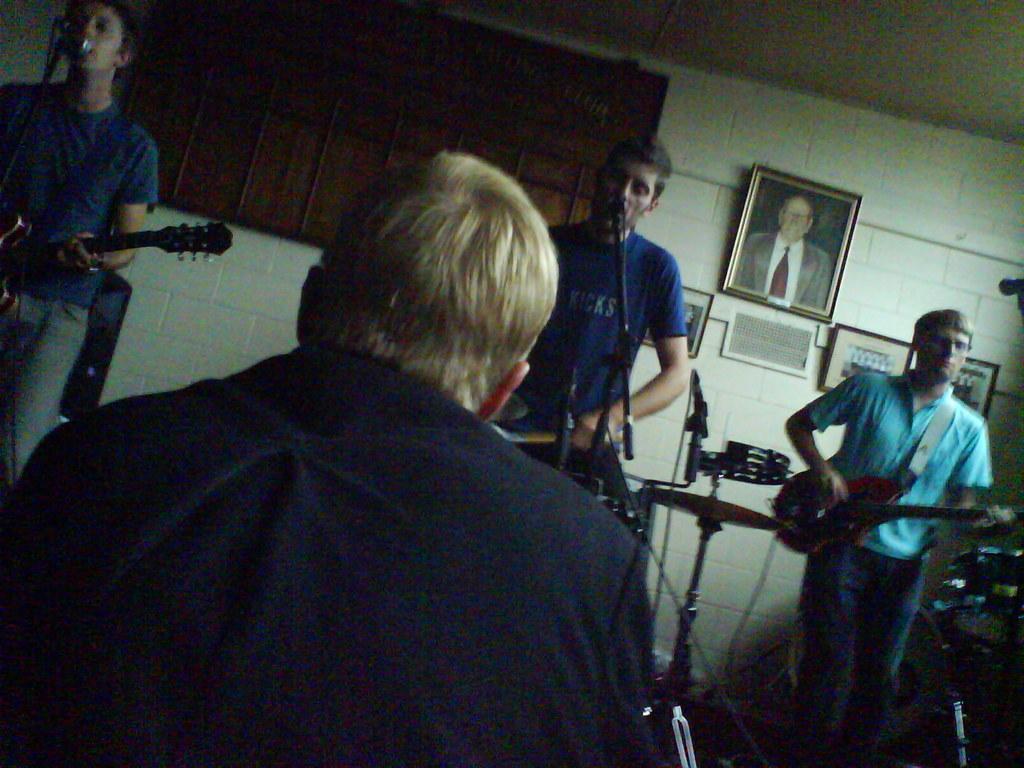How would you summarize this image in a sentence or two? This picture shows four people were three are playing musical instruments and a man Seated and we see a photo frame on the wall. 